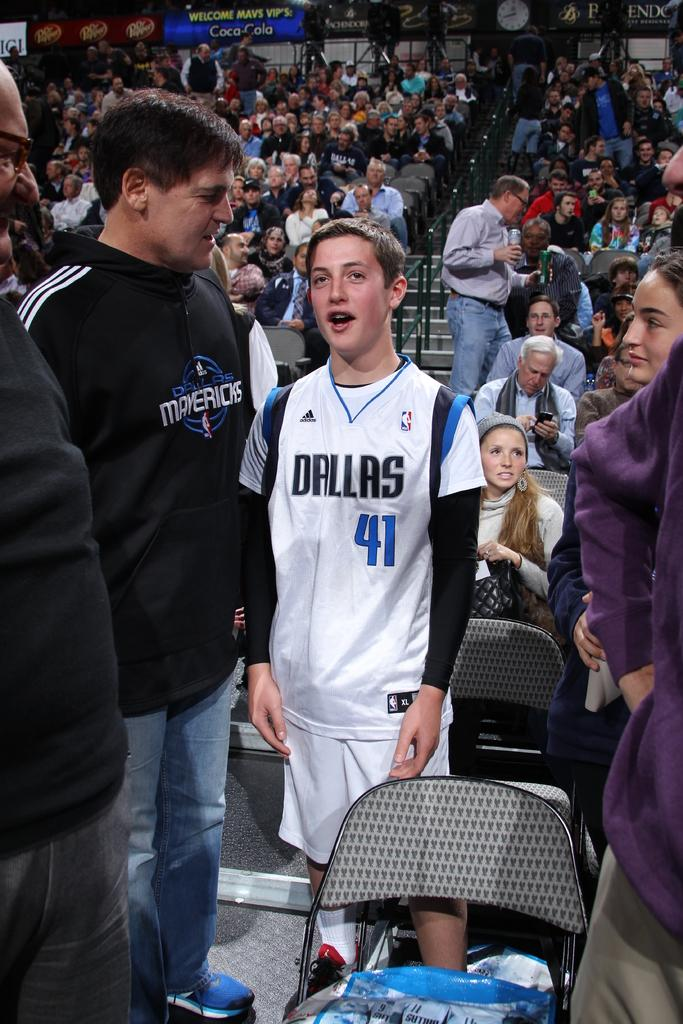<image>
Offer a succinct explanation of the picture presented. the city of Dallas is on the front of the jersey 